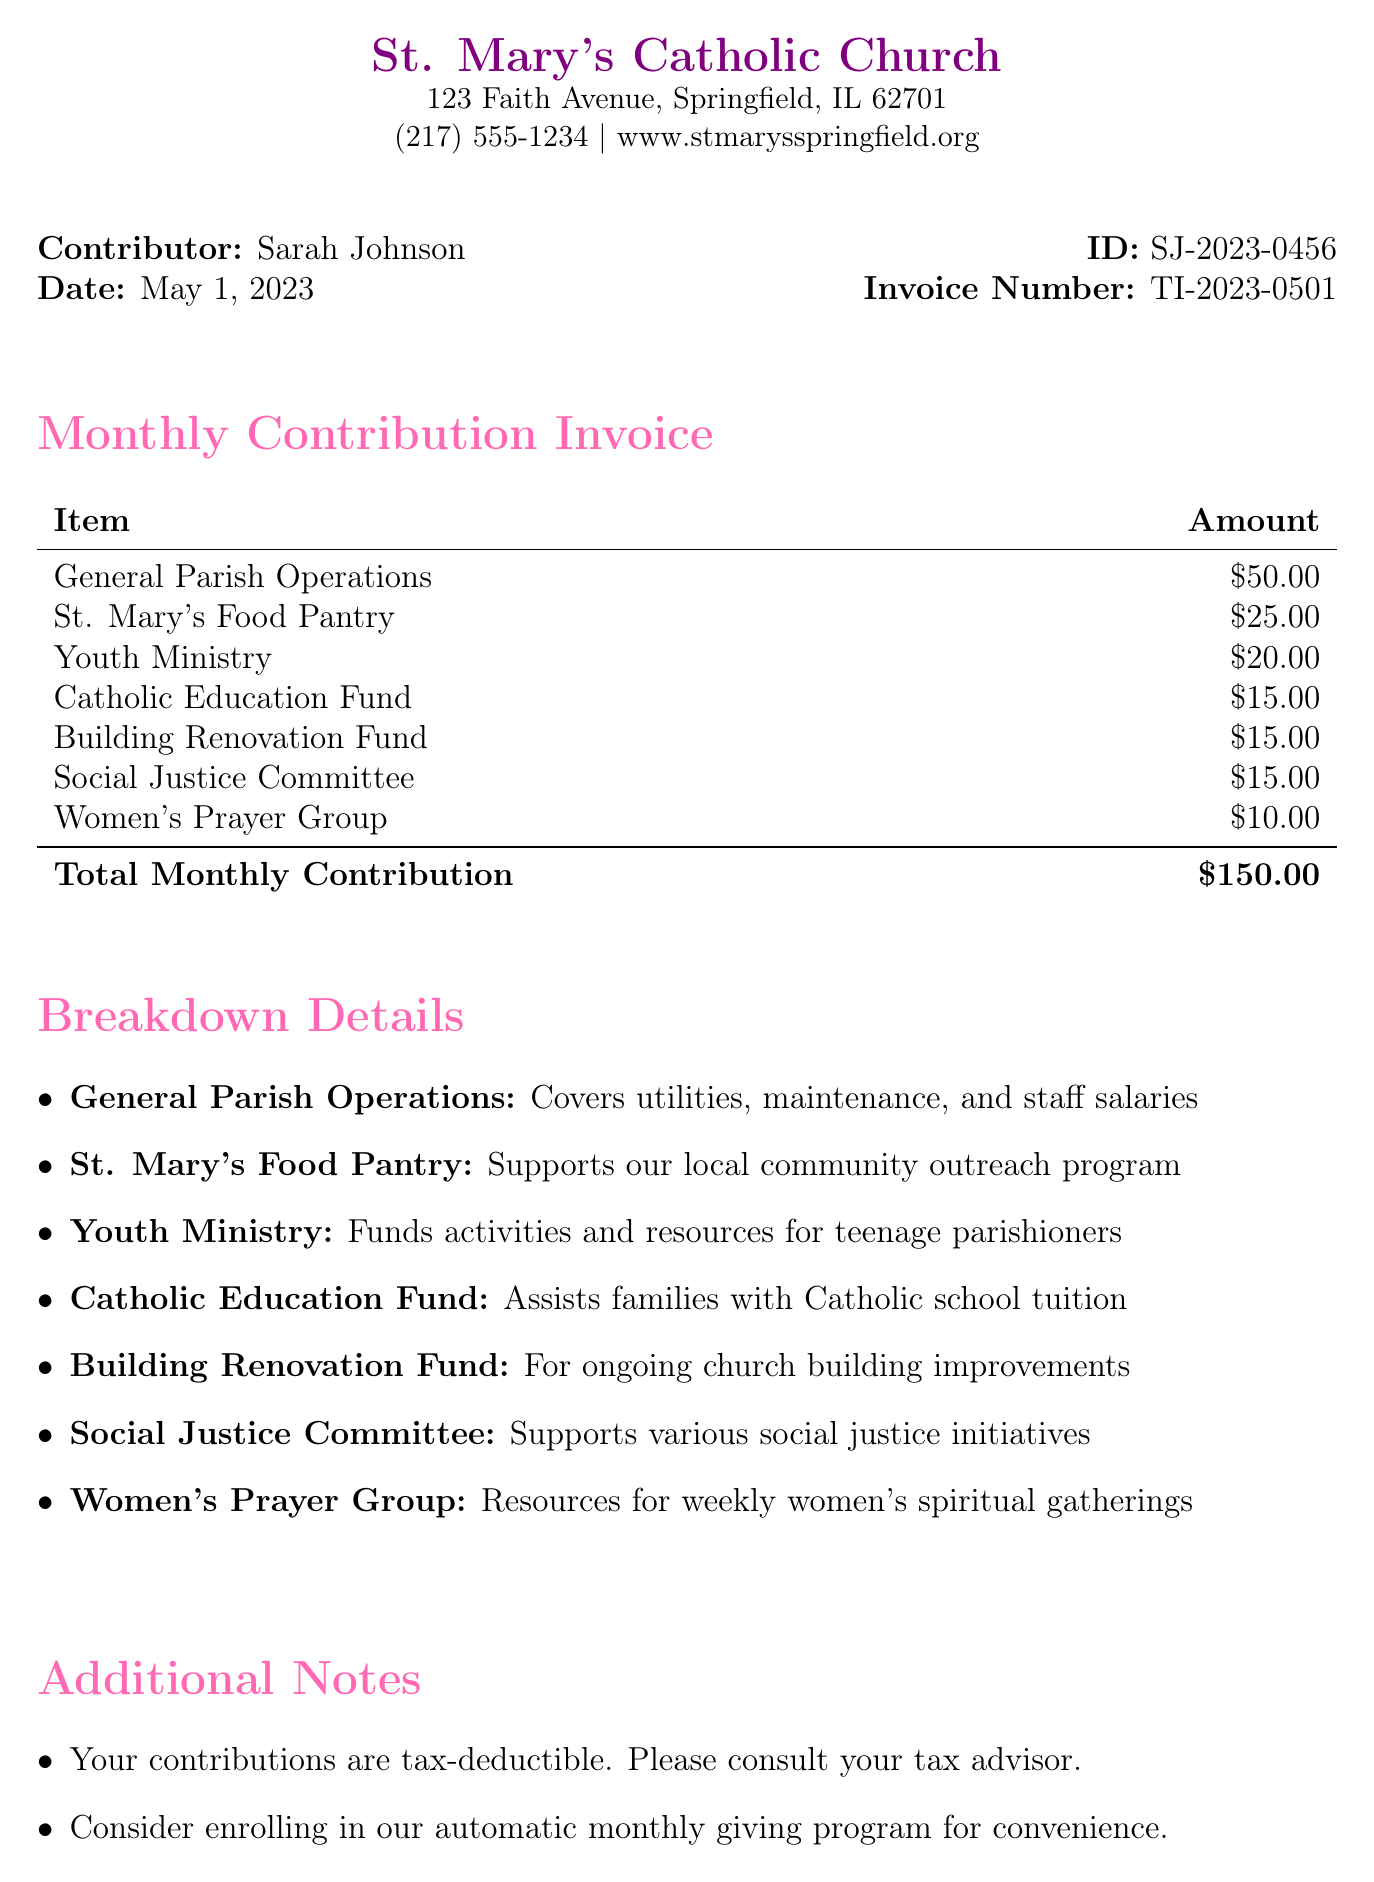What is the name of the church? The church name is explicitly mentioned in the document.
Answer: St. Mary's Catholic Church What date is the invoice dated? The date is clearly stated as the invoice date in the document.
Answer: May 1, 2023 How much is the total monthly contribution? The total monthly contribution is summarized at the bottom of the invoice.
Answer: $150.00 Who is the contributor? The contributor's name is provided in the document.
Answer: Sarah Johnson What is the amount allocated to the Youth Ministry? The specific amount for this program can be found in the breakdown of monthly contributions.
Answer: $20.00 What type of payment methods are accepted? The document lists the available payment methods for contributions.
Answer: Check, Online giving, Cash How many programs are funded by the contributions? The number of distinct funded programs is indicated in the breakdown section.
Answer: 7 What is one of the additional notes related to tax? The document includes specific notes about tax deductions.
Answer: Your contributions are tax-deductible What is the disclaimer about? The disclaimer addresses a sensitive issue concerning contribution allocation.
Answer: Portion may support pro-life initiatives 